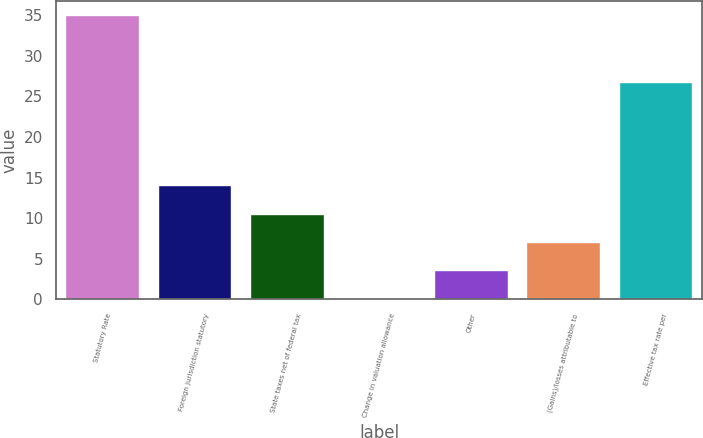<chart> <loc_0><loc_0><loc_500><loc_500><bar_chart><fcel>Statutory Rate<fcel>Foreign jurisdiction statutory<fcel>State taxes net of federal tax<fcel>Change in valuation allowance<fcel>Other<fcel>(Gains)/losses attributable to<fcel>Effective tax rate per<nl><fcel>35<fcel>14.06<fcel>10.57<fcel>0.1<fcel>3.59<fcel>7.08<fcel>26.8<nl></chart> 